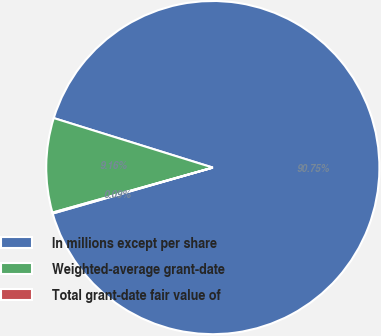Convert chart. <chart><loc_0><loc_0><loc_500><loc_500><pie_chart><fcel>In millions except per share<fcel>Weighted-average grant-date<fcel>Total grant-date fair value of<nl><fcel>90.75%<fcel>9.16%<fcel>0.09%<nl></chart> 